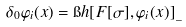Convert formula to latex. <formula><loc_0><loc_0><loc_500><loc_500>\delta _ { 0 } \varphi _ { i } ( x ) = \i h [ F [ \sigma ] , \varphi _ { i } ( x ) ] _ { \_ }</formula> 